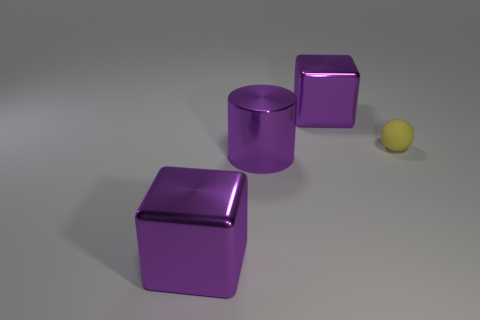There is a large object that is right of the large purple cylinder in front of the purple object that is behind the rubber object; what shape is it? The large object to the right of the purple cylinder and in front of another purple object, which is positioned behind a rubber item, is a cube. This cube has a shiny, reflective surface suggesting it's made of a smooth material, such as polished plastic or metal. Its distinct edges and flat faces are characteristic of a cube shape. 